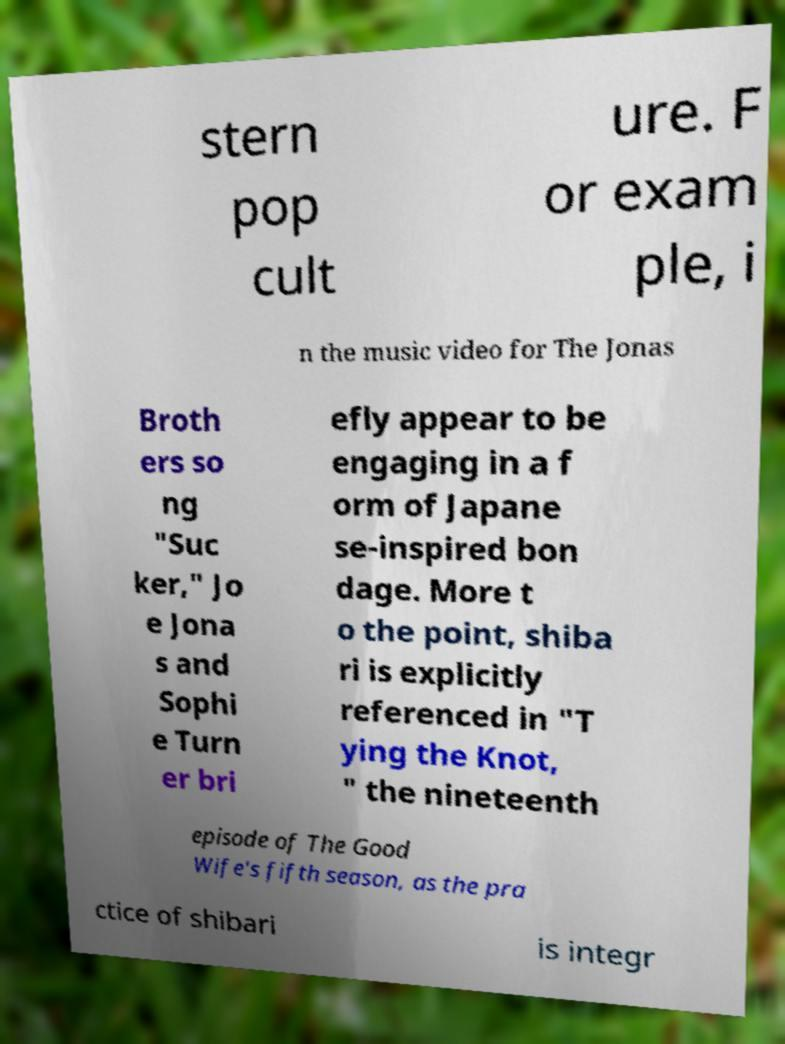Could you extract and type out the text from this image? stern pop cult ure. F or exam ple, i n the music video for The Jonas Broth ers so ng "Suc ker," Jo e Jona s and Sophi e Turn er bri efly appear to be engaging in a f orm of Japane se-inspired bon dage. More t o the point, shiba ri is explicitly referenced in "T ying the Knot, " the nineteenth episode of The Good Wife's fifth season, as the pra ctice of shibari is integr 